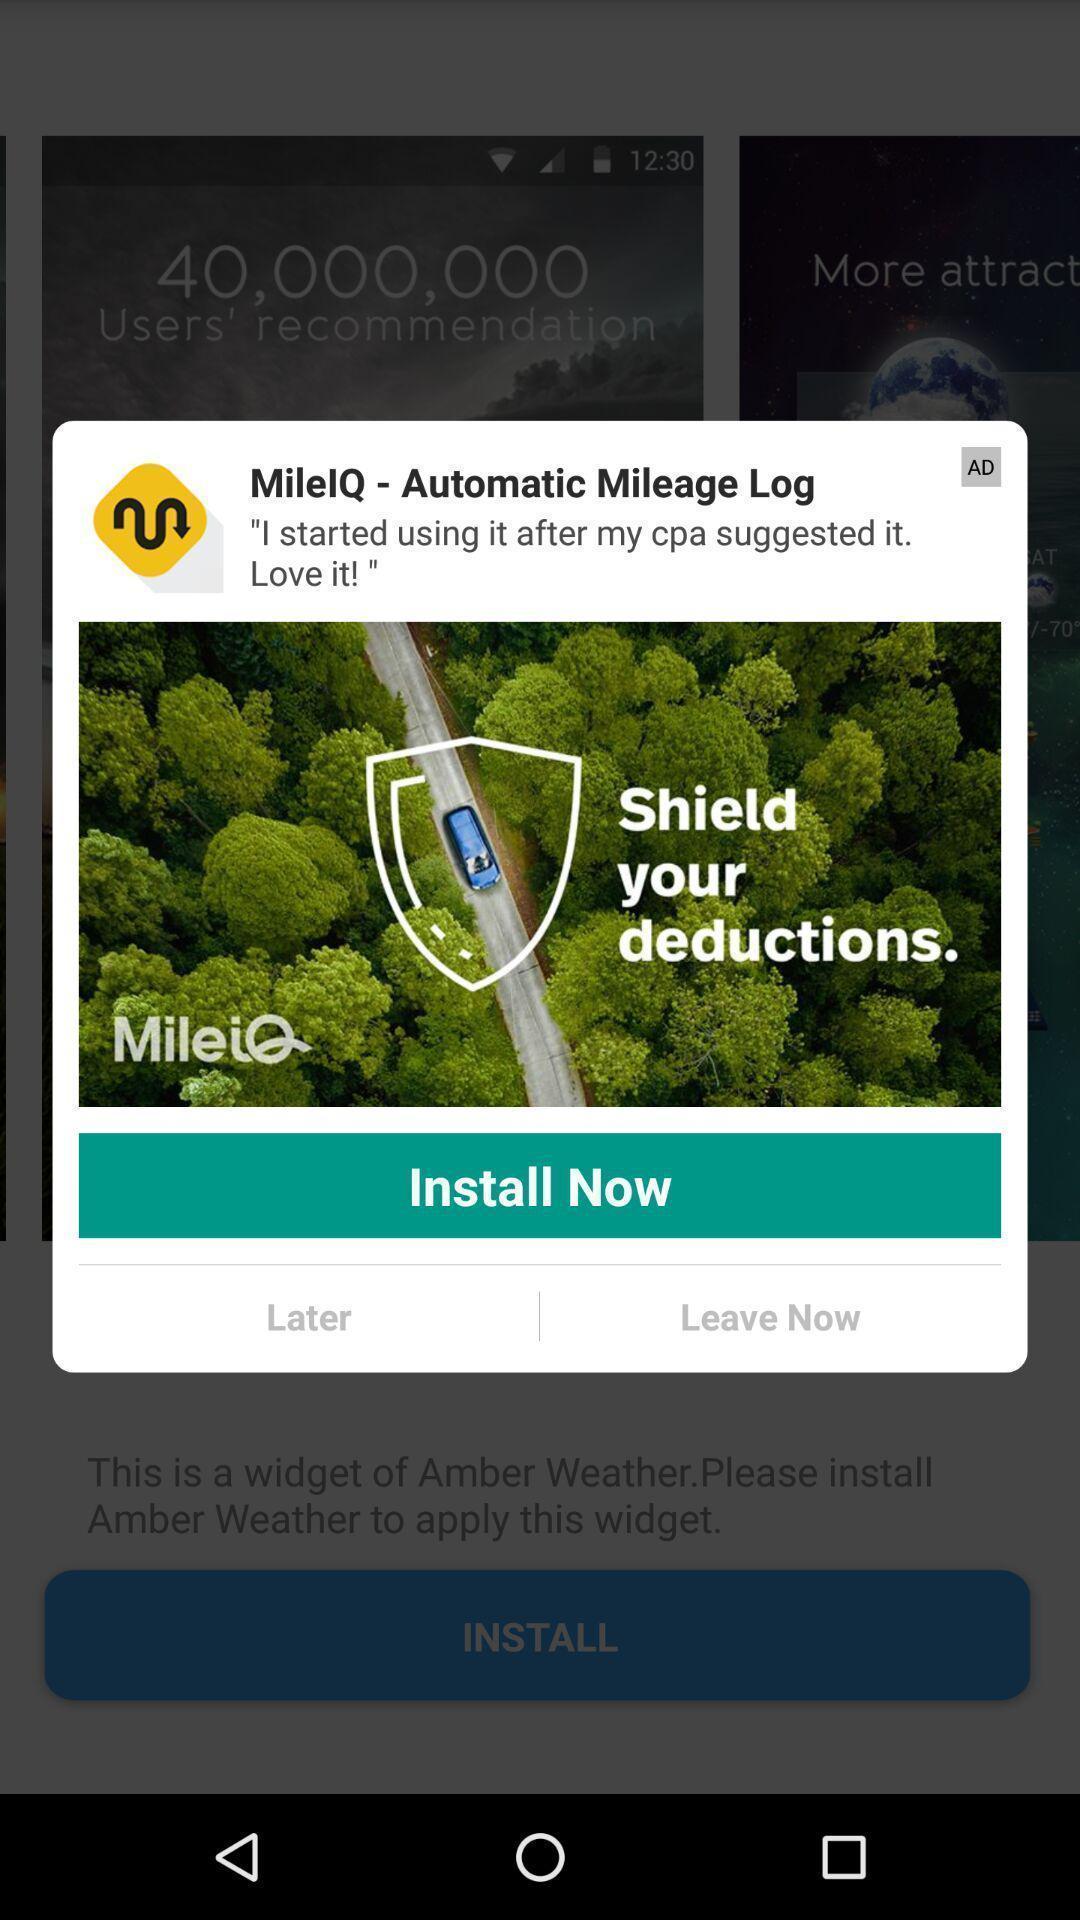Tell me about the visual elements in this screen capture. Popup asking to install the weather app. 